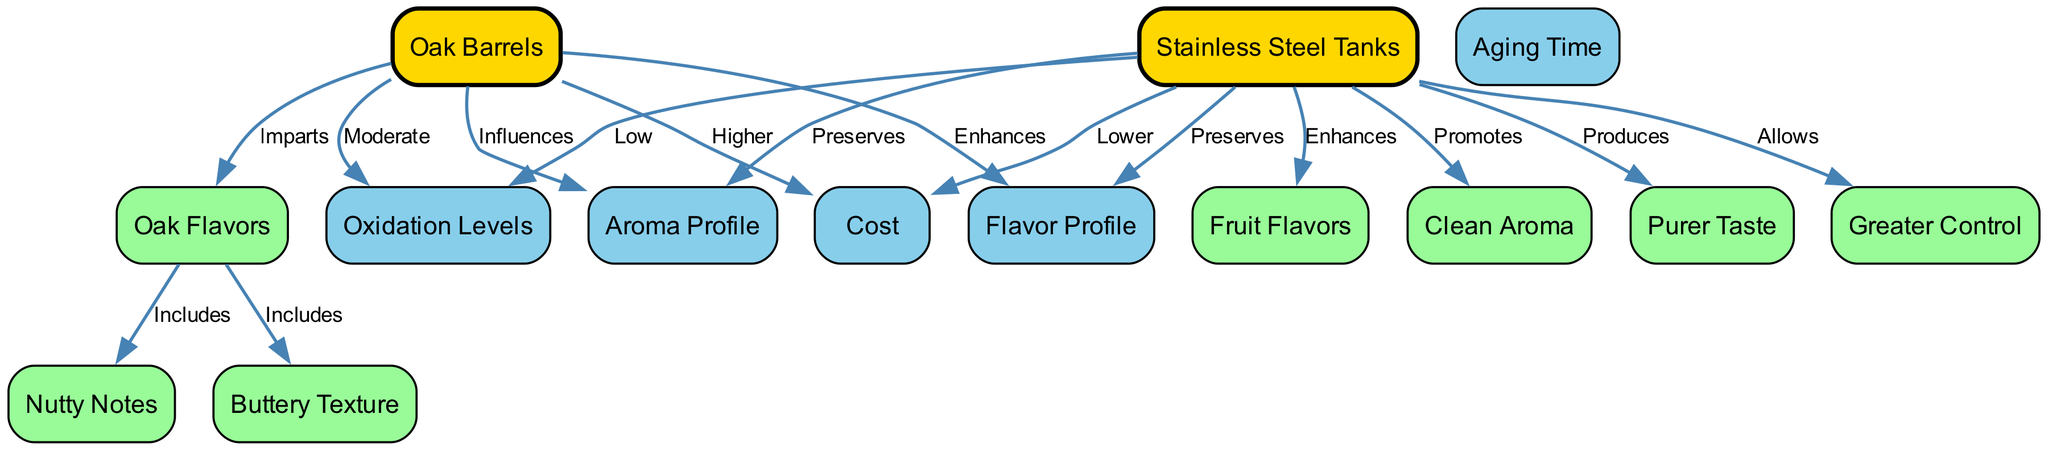What is the aging time for oak barrels? The diagram does not provide a specific duration for aging time directly under the 'oak barrels' node, indicating that this information may not be explicitly covered.
Answer: Not specified What flavor profile does oak barrels enhance? The diagram shows that oak barrels enhance the flavor profile by connecting the 'oak_barrels' node to the 'flavor_profile' node with the edge labeled 'Enhances'.
Answer: Flavor Profile What aroma profile is preserved by stainless steel tanks? The connection from the 'stainless_steel_tanks' node to the 'aroma_profile' node is labeled 'Preserves', indicating that the aroma profile is preserved through stainless steel tanks.
Answer: Aroma Profile How many nodes are in the diagram? By counting all unique nodes related to oak barrels, stainless steel tanks, flavor profiles, aroma profiles, and various influences, there are 13 nodes total.
Answer: 13 What is the cost difference between oak barrels and stainless steel tanks? Oak barrels have a 'Higher' cost compared to stainless steel tanks, which have a 'Lower' cost, indicating a clear difference.
Answer: Higher / Lower Which aging method imparts oak flavors? The diagram connects the 'oak_barrels' node to 'oak_flavors' with the edge labeled 'Imparts', indicating that oak barrels are responsible for imparting oak flavors.
Answer: Oak Barrels What kind of taste do stainless steel tanks produce? The edge emerging from 'stainless_steel_tanks' to 'purer_taste' is labeled 'Produces', indicating that the tanks produce a purer taste in wine.
Answer: Purer Taste What kind of notes are included in oak flavors? The oak flavors connect to the 'nutty' and 'buttery' nodes through edges labeled 'Includes', indicating both types of notes are included.
Answer: Nutty Notes, Buttery Texture What oxidation level is associated with stainless steel tanks? The connection from the 'stainless_steel_tanks' node indicates a 'Low' oxidation level, as per the label of the edge leading to 'oxidation_levels'.
Answer: Low 